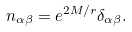<formula> <loc_0><loc_0><loc_500><loc_500>n _ { \alpha \beta } = e ^ { 2 M / r } \delta _ { \alpha \beta } .</formula> 